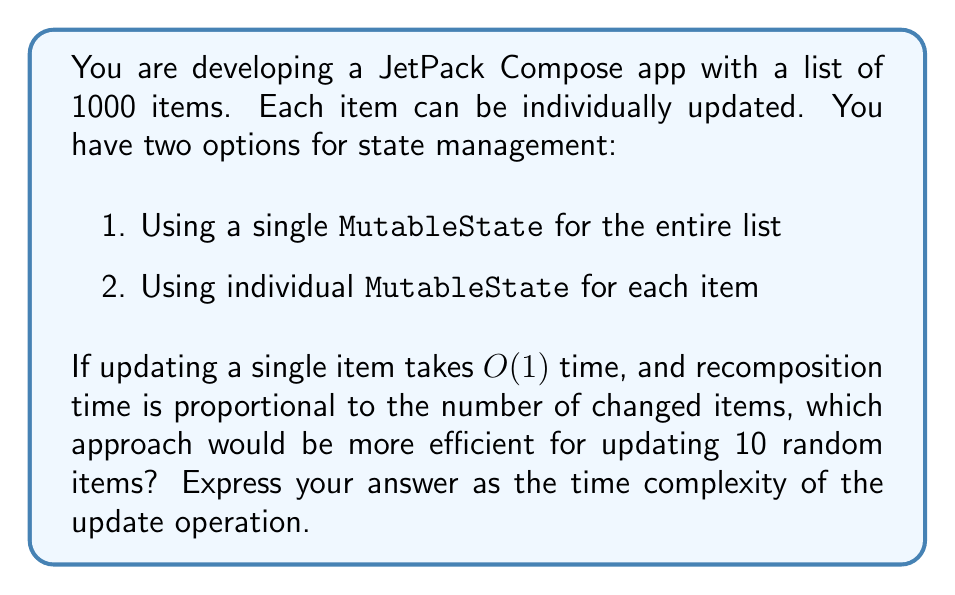Give your solution to this math problem. Let's analyze both approaches:

1. Single `MutableState` for the entire list:
   - Updating an item: $O(1)$
   - However, when we update the state, Compose treats the entire list as changed
   - Recomposition time: $O(n)$, where $n$ is the total number of items (1000)
   - Total time for updating 10 items: $10 \times (O(1) + O(n)) = O(n)$

2. Individual `MutableState` for each item:
   - Updating an item: $O(1)$
   - Only the changed items trigger recomposition
   - Recomposition time for each item: $O(1)$
   - Total time for updating 10 items: $10 \times (O(1) + O(1)) = O(1)$

In the first approach, regardless of how many items we update, we always trigger a full list recomposition, resulting in $O(n)$ time complexity.

In the second approach, we only recompose the changed items, so the time complexity remains constant regardless of the total list size.

Therefore, for updating 10 random items, the second approach with individual `MutableState` for each item is more efficient, with a time complexity of $O(1)$.
Answer: $O(1)$ 